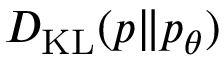Convert formula to latex. <formula><loc_0><loc_0><loc_500><loc_500>D _ { K L } ( p \| p _ { \theta } )</formula> 